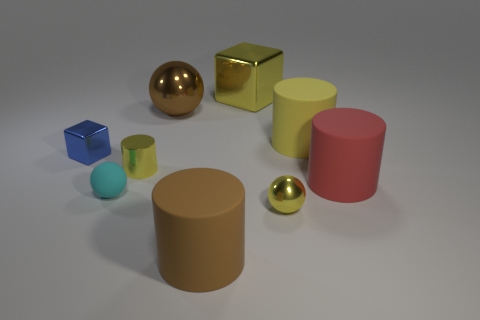Add 1 large matte blocks. How many objects exist? 10 Subtract all cylinders. How many objects are left? 5 Add 4 big brown cylinders. How many big brown cylinders exist? 5 Subtract 1 blue blocks. How many objects are left? 8 Subtract all brown rubber cylinders. Subtract all small blue objects. How many objects are left? 7 Add 5 brown things. How many brown things are left? 7 